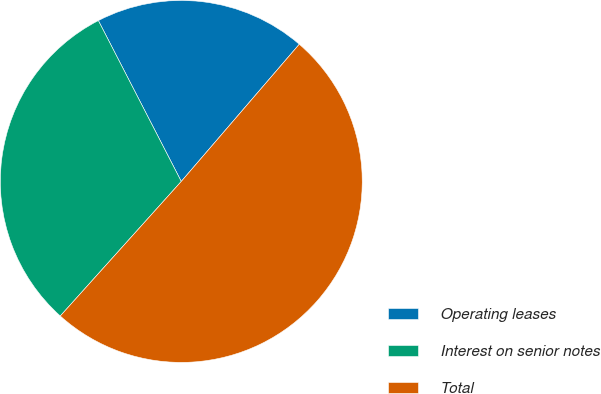Convert chart. <chart><loc_0><loc_0><loc_500><loc_500><pie_chart><fcel>Operating leases<fcel>Interest on senior notes<fcel>Total<nl><fcel>18.88%<fcel>30.77%<fcel>50.35%<nl></chart> 